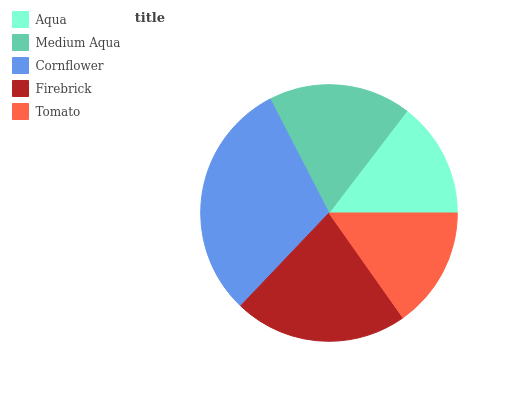Is Aqua the minimum?
Answer yes or no. Yes. Is Cornflower the maximum?
Answer yes or no. Yes. Is Medium Aqua the minimum?
Answer yes or no. No. Is Medium Aqua the maximum?
Answer yes or no. No. Is Medium Aqua greater than Aqua?
Answer yes or no. Yes. Is Aqua less than Medium Aqua?
Answer yes or no. Yes. Is Aqua greater than Medium Aqua?
Answer yes or no. No. Is Medium Aqua less than Aqua?
Answer yes or no. No. Is Medium Aqua the high median?
Answer yes or no. Yes. Is Medium Aqua the low median?
Answer yes or no. Yes. Is Aqua the high median?
Answer yes or no. No. Is Firebrick the low median?
Answer yes or no. No. 